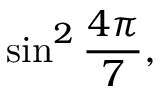<formula> <loc_0><loc_0><loc_500><loc_500>\sin ^ { 2 } { \frac { 4 \pi } { 7 } } ,</formula> 